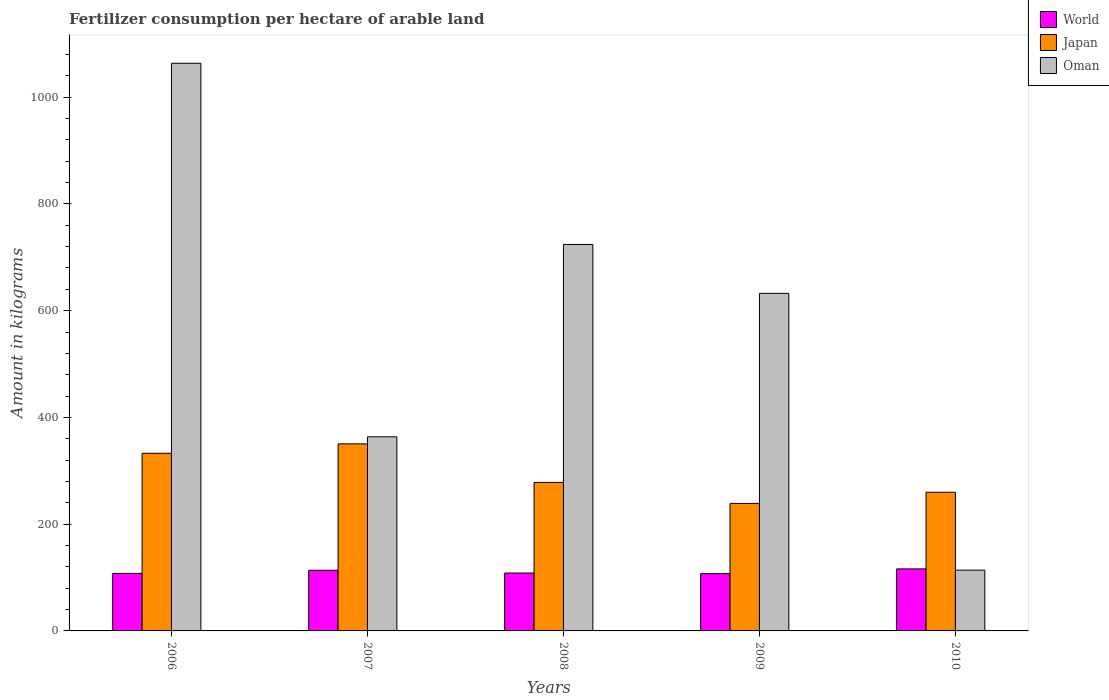How many different coloured bars are there?
Make the answer very short. 3. Are the number of bars per tick equal to the number of legend labels?
Offer a very short reply. Yes. Are the number of bars on each tick of the X-axis equal?
Your answer should be very brief. Yes. How many bars are there on the 4th tick from the left?
Offer a terse response. 3. How many bars are there on the 2nd tick from the right?
Your answer should be compact. 3. What is the amount of fertilizer consumption in World in 2006?
Your response must be concise. 107.79. Across all years, what is the maximum amount of fertilizer consumption in Oman?
Provide a succinct answer. 1063.62. Across all years, what is the minimum amount of fertilizer consumption in Japan?
Ensure brevity in your answer.  238.93. In which year was the amount of fertilizer consumption in Oman maximum?
Ensure brevity in your answer.  2006. What is the total amount of fertilizer consumption in Japan in the graph?
Your response must be concise. 1460.29. What is the difference between the amount of fertilizer consumption in Oman in 2006 and that in 2007?
Your answer should be compact. 699.87. What is the difference between the amount of fertilizer consumption in Oman in 2007 and the amount of fertilizer consumption in World in 2006?
Offer a very short reply. 255.96. What is the average amount of fertilizer consumption in World per year?
Give a very brief answer. 110.7. In the year 2008, what is the difference between the amount of fertilizer consumption in Oman and amount of fertilizer consumption in World?
Provide a succinct answer. 615.62. In how many years, is the amount of fertilizer consumption in Oman greater than 520 kg?
Offer a terse response. 3. What is the ratio of the amount of fertilizer consumption in World in 2006 to that in 2007?
Your answer should be compact. 0.95. What is the difference between the highest and the second highest amount of fertilizer consumption in Japan?
Your answer should be compact. 17.65. What is the difference between the highest and the lowest amount of fertilizer consumption in Oman?
Offer a very short reply. 949.74. What does the 2nd bar from the left in 2006 represents?
Give a very brief answer. Japan. What does the 2nd bar from the right in 2009 represents?
Offer a terse response. Japan. How many bars are there?
Make the answer very short. 15. Are all the bars in the graph horizontal?
Keep it short and to the point. No. How many years are there in the graph?
Your answer should be compact. 5. Does the graph contain any zero values?
Make the answer very short. No. How many legend labels are there?
Your answer should be very brief. 3. What is the title of the graph?
Offer a terse response. Fertilizer consumption per hectare of arable land. Does "Suriname" appear as one of the legend labels in the graph?
Your answer should be compact. No. What is the label or title of the Y-axis?
Your response must be concise. Amount in kilograms. What is the Amount in kilograms in World in 2006?
Provide a succinct answer. 107.79. What is the Amount in kilograms of Japan in 2006?
Keep it short and to the point. 332.83. What is the Amount in kilograms of Oman in 2006?
Your answer should be very brief. 1063.62. What is the Amount in kilograms in World in 2007?
Your response must be concise. 113.61. What is the Amount in kilograms of Japan in 2007?
Provide a succinct answer. 350.47. What is the Amount in kilograms of Oman in 2007?
Offer a terse response. 363.75. What is the Amount in kilograms in World in 2008?
Provide a short and direct response. 108.48. What is the Amount in kilograms in Japan in 2008?
Your response must be concise. 278.23. What is the Amount in kilograms in Oman in 2008?
Your answer should be compact. 724.1. What is the Amount in kilograms of World in 2009?
Your answer should be compact. 107.4. What is the Amount in kilograms in Japan in 2009?
Make the answer very short. 238.93. What is the Amount in kilograms in Oman in 2009?
Make the answer very short. 632.43. What is the Amount in kilograms in World in 2010?
Offer a very short reply. 116.21. What is the Amount in kilograms in Japan in 2010?
Your answer should be compact. 259.83. What is the Amount in kilograms in Oman in 2010?
Keep it short and to the point. 113.88. Across all years, what is the maximum Amount in kilograms in World?
Ensure brevity in your answer.  116.21. Across all years, what is the maximum Amount in kilograms in Japan?
Your answer should be compact. 350.47. Across all years, what is the maximum Amount in kilograms of Oman?
Give a very brief answer. 1063.62. Across all years, what is the minimum Amount in kilograms of World?
Offer a terse response. 107.4. Across all years, what is the minimum Amount in kilograms of Japan?
Make the answer very short. 238.93. Across all years, what is the minimum Amount in kilograms in Oman?
Keep it short and to the point. 113.88. What is the total Amount in kilograms in World in the graph?
Offer a very short reply. 553.49. What is the total Amount in kilograms of Japan in the graph?
Your answer should be compact. 1460.29. What is the total Amount in kilograms in Oman in the graph?
Provide a succinct answer. 2897.78. What is the difference between the Amount in kilograms in World in 2006 and that in 2007?
Provide a succinct answer. -5.81. What is the difference between the Amount in kilograms in Japan in 2006 and that in 2007?
Offer a terse response. -17.65. What is the difference between the Amount in kilograms in Oman in 2006 and that in 2007?
Provide a short and direct response. 699.87. What is the difference between the Amount in kilograms of World in 2006 and that in 2008?
Offer a terse response. -0.69. What is the difference between the Amount in kilograms of Japan in 2006 and that in 2008?
Provide a short and direct response. 54.6. What is the difference between the Amount in kilograms of Oman in 2006 and that in 2008?
Ensure brevity in your answer.  339.52. What is the difference between the Amount in kilograms in World in 2006 and that in 2009?
Ensure brevity in your answer.  0.4. What is the difference between the Amount in kilograms of Japan in 2006 and that in 2009?
Give a very brief answer. 93.9. What is the difference between the Amount in kilograms in Oman in 2006 and that in 2009?
Your answer should be compact. 431.18. What is the difference between the Amount in kilograms of World in 2006 and that in 2010?
Offer a terse response. -8.42. What is the difference between the Amount in kilograms in Japan in 2006 and that in 2010?
Ensure brevity in your answer.  72.99. What is the difference between the Amount in kilograms of Oman in 2006 and that in 2010?
Your answer should be compact. 949.74. What is the difference between the Amount in kilograms of World in 2007 and that in 2008?
Provide a short and direct response. 5.13. What is the difference between the Amount in kilograms in Japan in 2007 and that in 2008?
Provide a succinct answer. 72.25. What is the difference between the Amount in kilograms of Oman in 2007 and that in 2008?
Keep it short and to the point. -360.35. What is the difference between the Amount in kilograms of World in 2007 and that in 2009?
Provide a succinct answer. 6.21. What is the difference between the Amount in kilograms of Japan in 2007 and that in 2009?
Provide a short and direct response. 111.55. What is the difference between the Amount in kilograms in Oman in 2007 and that in 2009?
Provide a succinct answer. -268.68. What is the difference between the Amount in kilograms of World in 2007 and that in 2010?
Provide a short and direct response. -2.6. What is the difference between the Amount in kilograms in Japan in 2007 and that in 2010?
Keep it short and to the point. 90.64. What is the difference between the Amount in kilograms in Oman in 2007 and that in 2010?
Give a very brief answer. 249.87. What is the difference between the Amount in kilograms of World in 2008 and that in 2009?
Keep it short and to the point. 1.08. What is the difference between the Amount in kilograms of Japan in 2008 and that in 2009?
Provide a short and direct response. 39.3. What is the difference between the Amount in kilograms of Oman in 2008 and that in 2009?
Provide a short and direct response. 91.67. What is the difference between the Amount in kilograms of World in 2008 and that in 2010?
Your response must be concise. -7.73. What is the difference between the Amount in kilograms of Japan in 2008 and that in 2010?
Your answer should be very brief. 18.39. What is the difference between the Amount in kilograms of Oman in 2008 and that in 2010?
Your response must be concise. 610.22. What is the difference between the Amount in kilograms of World in 2009 and that in 2010?
Provide a short and direct response. -8.81. What is the difference between the Amount in kilograms of Japan in 2009 and that in 2010?
Ensure brevity in your answer.  -20.91. What is the difference between the Amount in kilograms of Oman in 2009 and that in 2010?
Make the answer very short. 518.55. What is the difference between the Amount in kilograms of World in 2006 and the Amount in kilograms of Japan in 2007?
Your answer should be very brief. -242.68. What is the difference between the Amount in kilograms of World in 2006 and the Amount in kilograms of Oman in 2007?
Ensure brevity in your answer.  -255.96. What is the difference between the Amount in kilograms in Japan in 2006 and the Amount in kilograms in Oman in 2007?
Provide a succinct answer. -30.92. What is the difference between the Amount in kilograms in World in 2006 and the Amount in kilograms in Japan in 2008?
Your answer should be compact. -170.43. What is the difference between the Amount in kilograms of World in 2006 and the Amount in kilograms of Oman in 2008?
Offer a very short reply. -616.31. What is the difference between the Amount in kilograms of Japan in 2006 and the Amount in kilograms of Oman in 2008?
Give a very brief answer. -391.27. What is the difference between the Amount in kilograms of World in 2006 and the Amount in kilograms of Japan in 2009?
Give a very brief answer. -131.13. What is the difference between the Amount in kilograms of World in 2006 and the Amount in kilograms of Oman in 2009?
Keep it short and to the point. -524.64. What is the difference between the Amount in kilograms of Japan in 2006 and the Amount in kilograms of Oman in 2009?
Provide a short and direct response. -299.6. What is the difference between the Amount in kilograms in World in 2006 and the Amount in kilograms in Japan in 2010?
Your answer should be compact. -152.04. What is the difference between the Amount in kilograms of World in 2006 and the Amount in kilograms of Oman in 2010?
Provide a short and direct response. -6.08. What is the difference between the Amount in kilograms in Japan in 2006 and the Amount in kilograms in Oman in 2010?
Your response must be concise. 218.95. What is the difference between the Amount in kilograms of World in 2007 and the Amount in kilograms of Japan in 2008?
Your answer should be compact. -164.62. What is the difference between the Amount in kilograms in World in 2007 and the Amount in kilograms in Oman in 2008?
Offer a very short reply. -610.49. What is the difference between the Amount in kilograms in Japan in 2007 and the Amount in kilograms in Oman in 2008?
Your answer should be compact. -373.63. What is the difference between the Amount in kilograms in World in 2007 and the Amount in kilograms in Japan in 2009?
Keep it short and to the point. -125.32. What is the difference between the Amount in kilograms of World in 2007 and the Amount in kilograms of Oman in 2009?
Offer a terse response. -518.82. What is the difference between the Amount in kilograms in Japan in 2007 and the Amount in kilograms in Oman in 2009?
Your answer should be very brief. -281.96. What is the difference between the Amount in kilograms of World in 2007 and the Amount in kilograms of Japan in 2010?
Offer a very short reply. -146.23. What is the difference between the Amount in kilograms in World in 2007 and the Amount in kilograms in Oman in 2010?
Your answer should be very brief. -0.27. What is the difference between the Amount in kilograms of Japan in 2007 and the Amount in kilograms of Oman in 2010?
Provide a short and direct response. 236.6. What is the difference between the Amount in kilograms in World in 2008 and the Amount in kilograms in Japan in 2009?
Make the answer very short. -130.45. What is the difference between the Amount in kilograms in World in 2008 and the Amount in kilograms in Oman in 2009?
Make the answer very short. -523.95. What is the difference between the Amount in kilograms in Japan in 2008 and the Amount in kilograms in Oman in 2009?
Provide a succinct answer. -354.2. What is the difference between the Amount in kilograms of World in 2008 and the Amount in kilograms of Japan in 2010?
Provide a short and direct response. -151.35. What is the difference between the Amount in kilograms in World in 2008 and the Amount in kilograms in Oman in 2010?
Your response must be concise. -5.4. What is the difference between the Amount in kilograms in Japan in 2008 and the Amount in kilograms in Oman in 2010?
Your answer should be compact. 164.35. What is the difference between the Amount in kilograms of World in 2009 and the Amount in kilograms of Japan in 2010?
Provide a short and direct response. -152.44. What is the difference between the Amount in kilograms in World in 2009 and the Amount in kilograms in Oman in 2010?
Keep it short and to the point. -6.48. What is the difference between the Amount in kilograms of Japan in 2009 and the Amount in kilograms of Oman in 2010?
Provide a succinct answer. 125.05. What is the average Amount in kilograms in World per year?
Provide a succinct answer. 110.7. What is the average Amount in kilograms in Japan per year?
Offer a terse response. 292.06. What is the average Amount in kilograms of Oman per year?
Ensure brevity in your answer.  579.56. In the year 2006, what is the difference between the Amount in kilograms of World and Amount in kilograms of Japan?
Offer a very short reply. -225.03. In the year 2006, what is the difference between the Amount in kilograms in World and Amount in kilograms in Oman?
Your answer should be compact. -955.82. In the year 2006, what is the difference between the Amount in kilograms of Japan and Amount in kilograms of Oman?
Keep it short and to the point. -730.79. In the year 2007, what is the difference between the Amount in kilograms of World and Amount in kilograms of Japan?
Your answer should be compact. -236.87. In the year 2007, what is the difference between the Amount in kilograms of World and Amount in kilograms of Oman?
Make the answer very short. -250.14. In the year 2007, what is the difference between the Amount in kilograms in Japan and Amount in kilograms in Oman?
Offer a very short reply. -13.28. In the year 2008, what is the difference between the Amount in kilograms of World and Amount in kilograms of Japan?
Your response must be concise. -169.75. In the year 2008, what is the difference between the Amount in kilograms of World and Amount in kilograms of Oman?
Your response must be concise. -615.62. In the year 2008, what is the difference between the Amount in kilograms in Japan and Amount in kilograms in Oman?
Your answer should be very brief. -445.87. In the year 2009, what is the difference between the Amount in kilograms of World and Amount in kilograms of Japan?
Your answer should be compact. -131.53. In the year 2009, what is the difference between the Amount in kilograms in World and Amount in kilograms in Oman?
Your answer should be compact. -525.03. In the year 2009, what is the difference between the Amount in kilograms of Japan and Amount in kilograms of Oman?
Provide a short and direct response. -393.5. In the year 2010, what is the difference between the Amount in kilograms of World and Amount in kilograms of Japan?
Give a very brief answer. -143.62. In the year 2010, what is the difference between the Amount in kilograms in World and Amount in kilograms in Oman?
Your answer should be compact. 2.33. In the year 2010, what is the difference between the Amount in kilograms of Japan and Amount in kilograms of Oman?
Ensure brevity in your answer.  145.96. What is the ratio of the Amount in kilograms in World in 2006 to that in 2007?
Offer a terse response. 0.95. What is the ratio of the Amount in kilograms in Japan in 2006 to that in 2007?
Provide a short and direct response. 0.95. What is the ratio of the Amount in kilograms of Oman in 2006 to that in 2007?
Provide a succinct answer. 2.92. What is the ratio of the Amount in kilograms in World in 2006 to that in 2008?
Give a very brief answer. 0.99. What is the ratio of the Amount in kilograms in Japan in 2006 to that in 2008?
Provide a short and direct response. 1.2. What is the ratio of the Amount in kilograms of Oman in 2006 to that in 2008?
Your answer should be compact. 1.47. What is the ratio of the Amount in kilograms in World in 2006 to that in 2009?
Offer a terse response. 1. What is the ratio of the Amount in kilograms in Japan in 2006 to that in 2009?
Make the answer very short. 1.39. What is the ratio of the Amount in kilograms of Oman in 2006 to that in 2009?
Your response must be concise. 1.68. What is the ratio of the Amount in kilograms in World in 2006 to that in 2010?
Keep it short and to the point. 0.93. What is the ratio of the Amount in kilograms of Japan in 2006 to that in 2010?
Ensure brevity in your answer.  1.28. What is the ratio of the Amount in kilograms of Oman in 2006 to that in 2010?
Keep it short and to the point. 9.34. What is the ratio of the Amount in kilograms in World in 2007 to that in 2008?
Offer a very short reply. 1.05. What is the ratio of the Amount in kilograms in Japan in 2007 to that in 2008?
Offer a terse response. 1.26. What is the ratio of the Amount in kilograms in Oman in 2007 to that in 2008?
Provide a short and direct response. 0.5. What is the ratio of the Amount in kilograms in World in 2007 to that in 2009?
Provide a succinct answer. 1.06. What is the ratio of the Amount in kilograms of Japan in 2007 to that in 2009?
Ensure brevity in your answer.  1.47. What is the ratio of the Amount in kilograms in Oman in 2007 to that in 2009?
Make the answer very short. 0.58. What is the ratio of the Amount in kilograms of World in 2007 to that in 2010?
Provide a short and direct response. 0.98. What is the ratio of the Amount in kilograms in Japan in 2007 to that in 2010?
Offer a terse response. 1.35. What is the ratio of the Amount in kilograms in Oman in 2007 to that in 2010?
Keep it short and to the point. 3.19. What is the ratio of the Amount in kilograms in Japan in 2008 to that in 2009?
Your answer should be compact. 1.16. What is the ratio of the Amount in kilograms in Oman in 2008 to that in 2009?
Your answer should be very brief. 1.14. What is the ratio of the Amount in kilograms in World in 2008 to that in 2010?
Your answer should be very brief. 0.93. What is the ratio of the Amount in kilograms of Japan in 2008 to that in 2010?
Give a very brief answer. 1.07. What is the ratio of the Amount in kilograms in Oman in 2008 to that in 2010?
Offer a very short reply. 6.36. What is the ratio of the Amount in kilograms in World in 2009 to that in 2010?
Your response must be concise. 0.92. What is the ratio of the Amount in kilograms in Japan in 2009 to that in 2010?
Make the answer very short. 0.92. What is the ratio of the Amount in kilograms of Oman in 2009 to that in 2010?
Your answer should be very brief. 5.55. What is the difference between the highest and the second highest Amount in kilograms of World?
Your answer should be very brief. 2.6. What is the difference between the highest and the second highest Amount in kilograms in Japan?
Provide a short and direct response. 17.65. What is the difference between the highest and the second highest Amount in kilograms of Oman?
Your answer should be compact. 339.52. What is the difference between the highest and the lowest Amount in kilograms in World?
Keep it short and to the point. 8.81. What is the difference between the highest and the lowest Amount in kilograms of Japan?
Offer a terse response. 111.55. What is the difference between the highest and the lowest Amount in kilograms in Oman?
Make the answer very short. 949.74. 